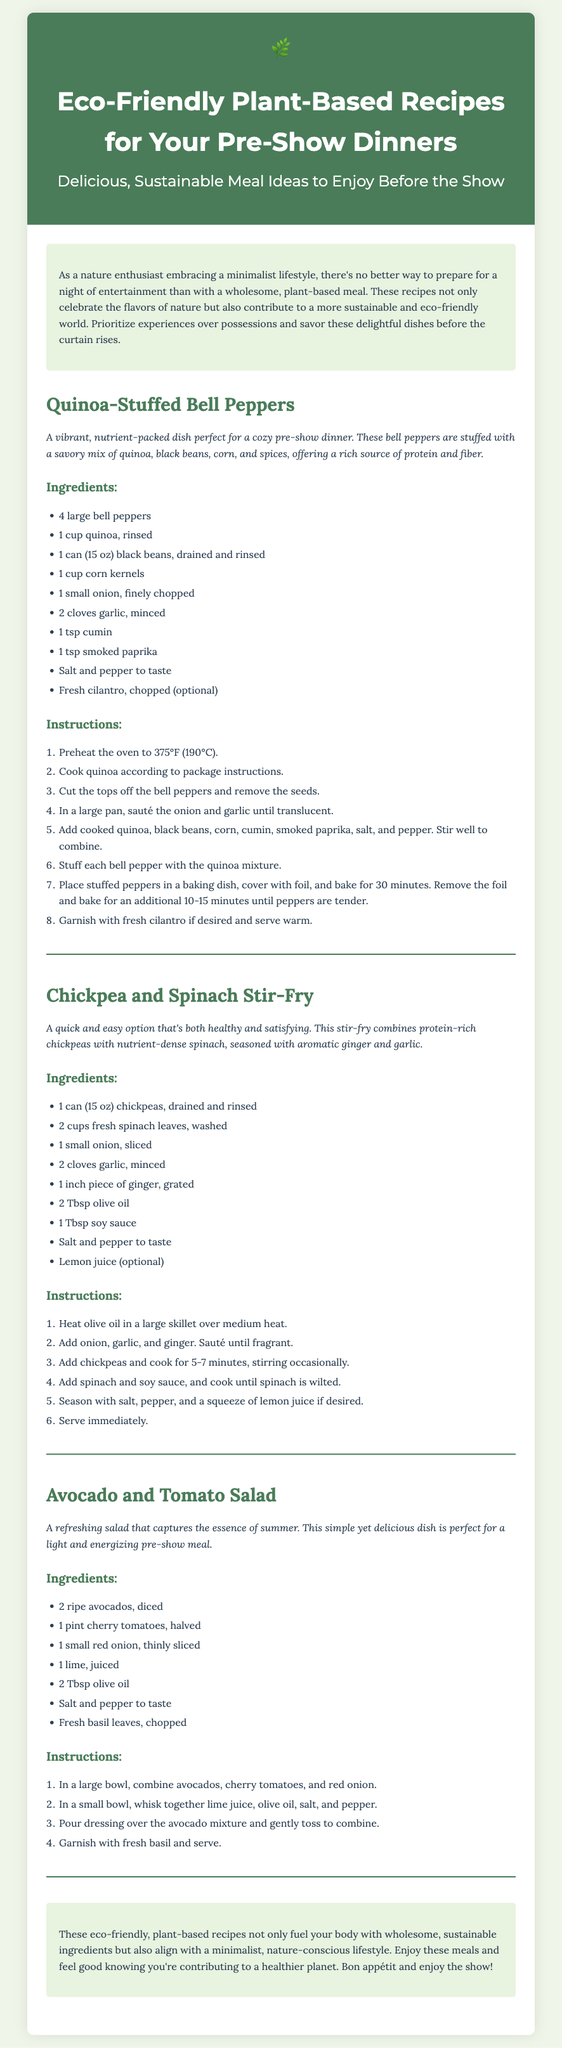What is the title of the Playbill? The title is prominently displayed at the top of the document.
Answer: Eco-Friendly Plant-Based Recipes for Your Pre-Show Dinners How many recipes are included in the Playbill? The document lists three distinct recipes in detail.
Answer: 3 What is a key ingredient in the Quinoa-Stuffed Bell Peppers? A specific ingredient is mentioned in the recipe section for Quinoa-Stuffed Bell Peppers.
Answer: Quinoa What dish includes chickpeas as a primary ingredient? The recipe section mentions this dish explicitly.
Answer: Chickpea and Spinach Stir-Fry What type of dressing is used in the Avocado and Tomato Salad? The ingredients section for the salad specifies the type used.
Answer: Olive oil and lime juice What cooking method is used for the Quinoa-Stuffed Bell Peppers? The instructions detail the method for preparing this dish.
Answer: Baking What meal philosophy does the Playbill emphasize? The introduction highlights a specific lifestyle approach.
Answer: Minimalist lifestyle What is the color scheme of the Playbill's header? The color information can be derived from the styling of the header section.
Answer: Green and white 